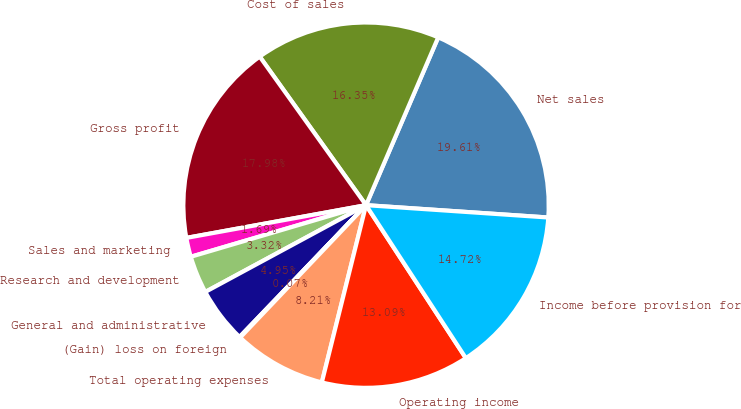Convert chart. <chart><loc_0><loc_0><loc_500><loc_500><pie_chart><fcel>Net sales<fcel>Cost of sales<fcel>Gross profit<fcel>Sales and marketing<fcel>Research and development<fcel>General and administrative<fcel>(Gain) loss on foreign<fcel>Total operating expenses<fcel>Operating income<fcel>Income before provision for<nl><fcel>19.61%<fcel>16.35%<fcel>17.98%<fcel>1.69%<fcel>3.32%<fcel>4.95%<fcel>0.07%<fcel>8.21%<fcel>13.09%<fcel>14.72%<nl></chart> 